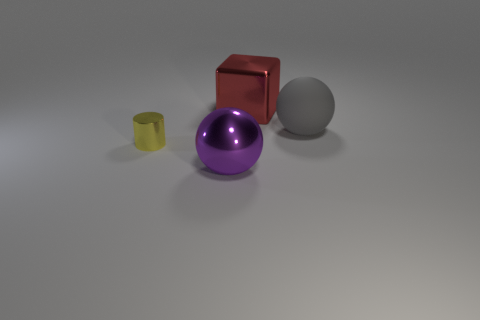Add 2 tiny brown spheres. How many objects exist? 6 Add 3 big gray matte things. How many big gray matte things exist? 4 Subtract 0 purple cylinders. How many objects are left? 4 Subtract all cubes. How many objects are left? 3 Subtract all blue balls. Subtract all yellow cubes. How many balls are left? 2 Subtract all gray rubber spheres. Subtract all blue matte objects. How many objects are left? 3 Add 2 big shiny blocks. How many big shiny blocks are left? 3 